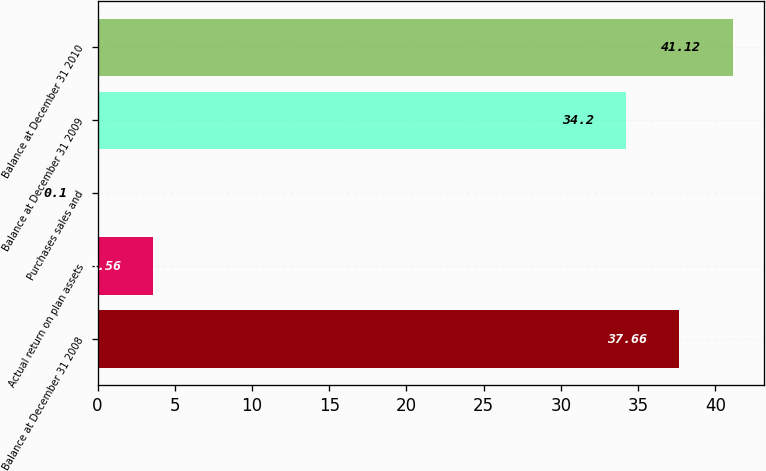Convert chart to OTSL. <chart><loc_0><loc_0><loc_500><loc_500><bar_chart><fcel>Balance at December 31 2008<fcel>Actual return on plan assets<fcel>Purchases sales and<fcel>Balance at December 31 2009<fcel>Balance at December 31 2010<nl><fcel>37.66<fcel>3.56<fcel>0.1<fcel>34.2<fcel>41.12<nl></chart> 